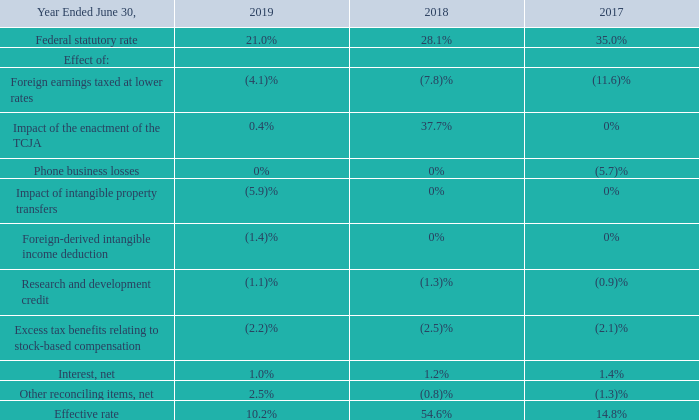Effective Tax Rate
The items accounting for the difference between income taxes computed at the U.S. federal statutory rate and our effective rate were as follows:
The decrease from the federal statutory rate in fiscal year 2019 is primarily due to a $2.6 billion net income tax benefit related to intangible property transfers, and earnings taxed at lower rates in foreign jurisdictions resulting from producing and distributing our products and services through our foreign regional operations centers in Ireland, Singapore, and Puerto Rico. The increase from the federal statutory rate in fiscal year 2018 is primarily due to the net charge related to the enactment of the TCJA in the second quarter of fiscal year 2018, offset in part by earnings taxed at lower rates in foreign jurisdictions. The decrease from the federal statutory rate in fiscal year 2017 is primarily due to earnings taxed at lower rates in foreign jurisdictions. Our foreign regional operating centers in Ireland, Singapore and Puerto Rico, which are taxed at rates lower than the U.S. rate, generated 82%, 87%, and 76% of our foreign income before tax in fiscal years 2019, 2018, and 2017, respectively. Other reconciling items, net consists primarily of tax credits, GILTI, and U.S. state income taxes. In fiscal years 2019, 2018, and 2017, there were no individually significant other reconciling items.
The decrease in our effective tax rate for fiscal year 2019 compared to fiscal year 2018 was primarily due to the net charge related to the enactment of the TCJA in the second quarter of fiscal year 2018, and a $2.6 billion net income tax benefit in the fourth quarter of fiscal year 2019 related to intangible property transfers. The increase in our effective tax rate for fiscal year 2018 compared to fiscal year 2017 was primarily due to the net charge related to the enactment of the TCJA and the realization of tax benefits attributable to previous Phone business losses in fiscal year 2017.
Why did effective tax rate in fiscal 2019 decrease from 2018? The decrease in our effective tax rate for fiscal year 2019 compared to fiscal year 2018 was primarily due to the net charge related to the enactment of the tcja in the second quarter of fiscal year 2018. Why did the federal statutory rate in fiscal year 2019 decrease from 2018? The decrease from the federal statutory rate in fiscal year 2019 is primarily due to a $2.6 billion net income tax benefit related to intangible property transfers, and earnings taxed at lower rates in foreign jurisdictions resulting from producing and distributing our products and services through our foreign regional operations centers in ireland, singapore, and puerto rico. Why did the federal statutory rate in fiscal year 2017?  The decrease from the federal statutory rate in fiscal year 2017 is primarily due to earnings taxed at lower rates in foreign jurisdictions. How many items accounted for the difference between income taxes computed at the US federal statutory rate and the company's effective rate? Foreign earnings taxed at lower rates##Impact of the enactment of the TCJA##Phone business losses##Impact of intangible property transfers##Foreign-derived intangible income deduction##Research and development credit##Excess tax benefits relating to stock-based compensation##Interest, net##Other reconciling items, net
Answer: 9. What was the average federal statutory rate over the 3 year period from 2017 to 2019? 
Answer scale should be: percent. (21.0+28.1+35.0)/3
Answer: 28.03. What was the average effective rate over the 3 year period from 2017 to 2019? 
Answer scale should be: percent. (10.2+54.6+14.8)/3
Answer: 26.53. 